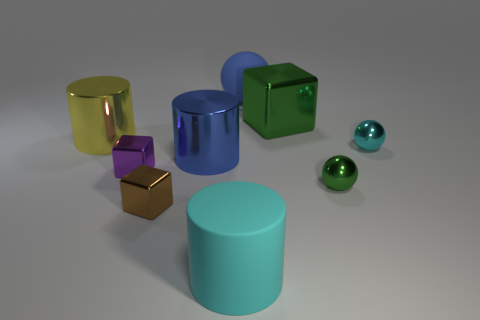What size is the green object that is left of the small green ball?
Your answer should be compact. Large. Are there any tiny shiny spheres that have the same color as the large block?
Offer a terse response. Yes. There is a big shiny object that is the same color as the big ball; what is its shape?
Your response must be concise. Cylinder. How many small blocks are right of the large matte thing that is in front of the big blue matte object?
Your answer should be compact. 0. How many purple cubes are the same material as the small cyan object?
Give a very brief answer. 1. There is a large green metal block; are there any objects to the left of it?
Offer a very short reply. Yes. There is a metallic ball that is the same size as the cyan metal thing; what is its color?
Your answer should be compact. Green. What number of objects are either cyan balls in front of the yellow thing or big matte blocks?
Provide a short and direct response. 1. What is the size of the object that is to the left of the large blue rubber object and behind the tiny cyan metal sphere?
Your answer should be compact. Large. What is the size of the shiny thing that is the same color as the large ball?
Your response must be concise. Large. 